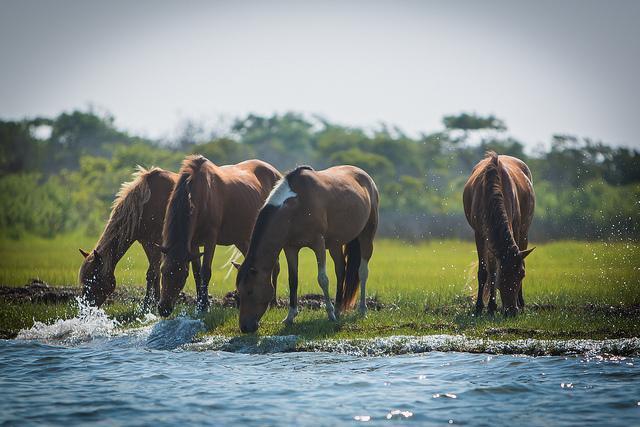How many horses are in this picture?
Give a very brief answer. 4. How many horses are there?
Give a very brief answer. 4. How many people in the picture?
Give a very brief answer. 0. 